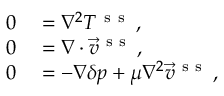Convert formula to latex. <formula><loc_0><loc_0><loc_500><loc_500>\begin{array} { r l } { 0 } & = \nabla ^ { 2 } T ^ { s s } \, , } \\ { 0 } & = \nabla \cdot \vec { v } ^ { s s } \, , } \\ { 0 } & = - \nabla \delta p + \mu \nabla ^ { 2 } \vec { v } ^ { s s } \, , } \end{array}</formula> 